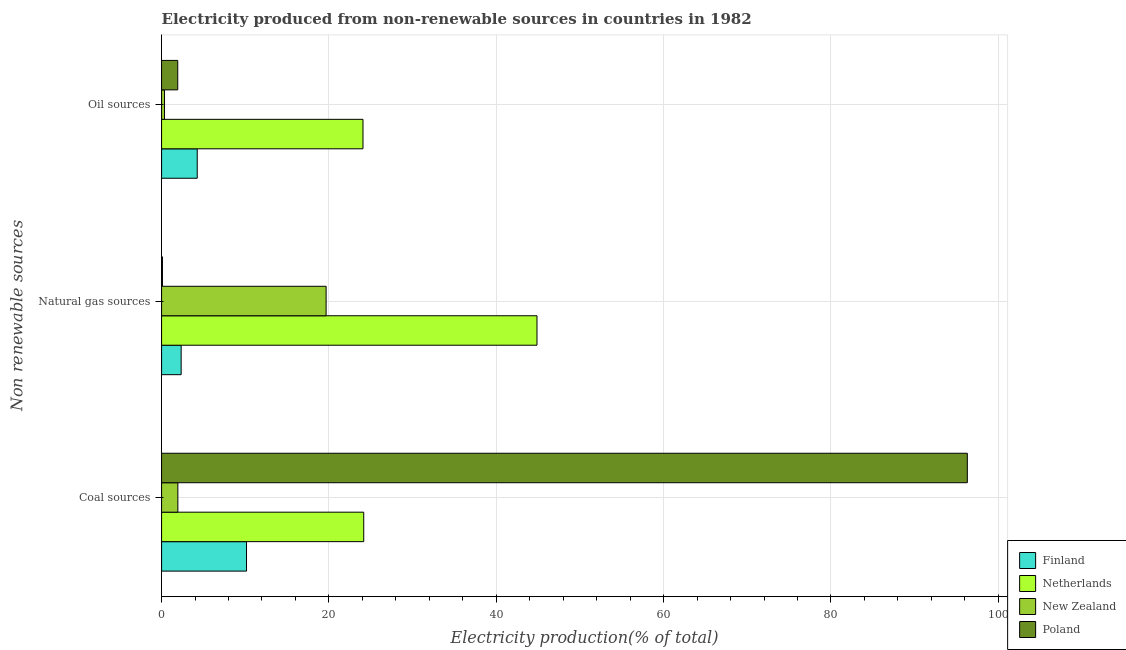How many different coloured bars are there?
Offer a terse response. 4. Are the number of bars per tick equal to the number of legend labels?
Provide a succinct answer. Yes. How many bars are there on the 1st tick from the top?
Ensure brevity in your answer.  4. What is the label of the 3rd group of bars from the top?
Your answer should be very brief. Coal sources. What is the percentage of electricity produced by oil sources in Finland?
Keep it short and to the point. 4.26. Across all countries, what is the maximum percentage of electricity produced by natural gas?
Give a very brief answer. 44.87. Across all countries, what is the minimum percentage of electricity produced by oil sources?
Give a very brief answer. 0.35. In which country was the percentage of electricity produced by coal minimum?
Provide a succinct answer. New Zealand. What is the total percentage of electricity produced by coal in the graph?
Give a very brief answer. 132.56. What is the difference between the percentage of electricity produced by oil sources in Netherlands and that in New Zealand?
Your response must be concise. 23.72. What is the difference between the percentage of electricity produced by coal in Netherlands and the percentage of electricity produced by natural gas in New Zealand?
Your answer should be compact. 4.5. What is the average percentage of electricity produced by oil sources per country?
Provide a short and direct response. 7.65. What is the difference between the percentage of electricity produced by natural gas and percentage of electricity produced by coal in Finland?
Give a very brief answer. -7.81. What is the ratio of the percentage of electricity produced by oil sources in Poland to that in New Zealand?
Your answer should be very brief. 5.48. Is the percentage of electricity produced by natural gas in Netherlands less than that in Finland?
Your answer should be compact. No. Is the difference between the percentage of electricity produced by natural gas in Finland and Poland greater than the difference between the percentage of electricity produced by coal in Finland and Poland?
Your answer should be very brief. Yes. What is the difference between the highest and the second highest percentage of electricity produced by oil sources?
Your answer should be very brief. 19.81. What is the difference between the highest and the lowest percentage of electricity produced by oil sources?
Provide a short and direct response. 23.72. In how many countries, is the percentage of electricity produced by natural gas greater than the average percentage of electricity produced by natural gas taken over all countries?
Make the answer very short. 2. What does the 1st bar from the bottom in Natural gas sources represents?
Provide a short and direct response. Finland. How many bars are there?
Give a very brief answer. 12. Are all the bars in the graph horizontal?
Offer a very short reply. Yes. How many countries are there in the graph?
Give a very brief answer. 4. Are the values on the major ticks of X-axis written in scientific E-notation?
Make the answer very short. No. Does the graph contain any zero values?
Your answer should be very brief. No. Does the graph contain grids?
Offer a terse response. Yes. Where does the legend appear in the graph?
Your answer should be compact. Bottom right. How many legend labels are there?
Provide a succinct answer. 4. How are the legend labels stacked?
Offer a very short reply. Vertical. What is the title of the graph?
Offer a very short reply. Electricity produced from non-renewable sources in countries in 1982. What is the label or title of the X-axis?
Offer a very short reply. Electricity production(% of total). What is the label or title of the Y-axis?
Your response must be concise. Non renewable sources. What is the Electricity production(% of total) in Finland in Coal sources?
Provide a short and direct response. 10.15. What is the Electricity production(% of total) in Netherlands in Coal sources?
Your answer should be compact. 24.16. What is the Electricity production(% of total) in New Zealand in Coal sources?
Keep it short and to the point. 1.95. What is the Electricity production(% of total) of Poland in Coal sources?
Provide a succinct answer. 96.3. What is the Electricity production(% of total) in Finland in Natural gas sources?
Offer a very short reply. 2.34. What is the Electricity production(% of total) of Netherlands in Natural gas sources?
Ensure brevity in your answer.  44.87. What is the Electricity production(% of total) in New Zealand in Natural gas sources?
Provide a short and direct response. 19.66. What is the Electricity production(% of total) in Poland in Natural gas sources?
Make the answer very short. 0.11. What is the Electricity production(% of total) in Finland in Oil sources?
Keep it short and to the point. 4.26. What is the Electricity production(% of total) in Netherlands in Oil sources?
Your response must be concise. 24.07. What is the Electricity production(% of total) of New Zealand in Oil sources?
Provide a succinct answer. 0.35. What is the Electricity production(% of total) of Poland in Oil sources?
Provide a succinct answer. 1.93. Across all Non renewable sources, what is the maximum Electricity production(% of total) of Finland?
Offer a very short reply. 10.15. Across all Non renewable sources, what is the maximum Electricity production(% of total) in Netherlands?
Offer a very short reply. 44.87. Across all Non renewable sources, what is the maximum Electricity production(% of total) of New Zealand?
Offer a very short reply. 19.66. Across all Non renewable sources, what is the maximum Electricity production(% of total) in Poland?
Your answer should be very brief. 96.3. Across all Non renewable sources, what is the minimum Electricity production(% of total) of Finland?
Offer a very short reply. 2.34. Across all Non renewable sources, what is the minimum Electricity production(% of total) of Netherlands?
Give a very brief answer. 24.07. Across all Non renewable sources, what is the minimum Electricity production(% of total) in New Zealand?
Your answer should be compact. 0.35. Across all Non renewable sources, what is the minimum Electricity production(% of total) in Poland?
Provide a succinct answer. 0.11. What is the total Electricity production(% of total) in Finland in the graph?
Provide a succinct answer. 16.76. What is the total Electricity production(% of total) of Netherlands in the graph?
Provide a short and direct response. 93.1. What is the total Electricity production(% of total) of New Zealand in the graph?
Your response must be concise. 21.96. What is the total Electricity production(% of total) of Poland in the graph?
Your response must be concise. 98.34. What is the difference between the Electricity production(% of total) of Finland in Coal sources and that in Natural gas sources?
Offer a terse response. 7.81. What is the difference between the Electricity production(% of total) of Netherlands in Coal sources and that in Natural gas sources?
Offer a terse response. -20.71. What is the difference between the Electricity production(% of total) of New Zealand in Coal sources and that in Natural gas sources?
Your answer should be compact. -17.72. What is the difference between the Electricity production(% of total) in Poland in Coal sources and that in Natural gas sources?
Your response must be concise. 96.19. What is the difference between the Electricity production(% of total) of Finland in Coal sources and that in Oil sources?
Keep it short and to the point. 5.89. What is the difference between the Electricity production(% of total) of Netherlands in Coal sources and that in Oil sources?
Your answer should be very brief. 0.09. What is the difference between the Electricity production(% of total) in New Zealand in Coal sources and that in Oil sources?
Offer a terse response. 1.59. What is the difference between the Electricity production(% of total) of Poland in Coal sources and that in Oil sources?
Offer a very short reply. 94.37. What is the difference between the Electricity production(% of total) of Finland in Natural gas sources and that in Oil sources?
Offer a terse response. -1.92. What is the difference between the Electricity production(% of total) of Netherlands in Natural gas sources and that in Oil sources?
Keep it short and to the point. 20.8. What is the difference between the Electricity production(% of total) in New Zealand in Natural gas sources and that in Oil sources?
Offer a terse response. 19.31. What is the difference between the Electricity production(% of total) of Poland in Natural gas sources and that in Oil sources?
Give a very brief answer. -1.83. What is the difference between the Electricity production(% of total) of Finland in Coal sources and the Electricity production(% of total) of Netherlands in Natural gas sources?
Keep it short and to the point. -34.71. What is the difference between the Electricity production(% of total) of Finland in Coal sources and the Electricity production(% of total) of New Zealand in Natural gas sources?
Provide a short and direct response. -9.51. What is the difference between the Electricity production(% of total) of Finland in Coal sources and the Electricity production(% of total) of Poland in Natural gas sources?
Provide a succinct answer. 10.05. What is the difference between the Electricity production(% of total) in Netherlands in Coal sources and the Electricity production(% of total) in New Zealand in Natural gas sources?
Provide a short and direct response. 4.5. What is the difference between the Electricity production(% of total) of Netherlands in Coal sources and the Electricity production(% of total) of Poland in Natural gas sources?
Give a very brief answer. 24.06. What is the difference between the Electricity production(% of total) in New Zealand in Coal sources and the Electricity production(% of total) in Poland in Natural gas sources?
Provide a short and direct response. 1.84. What is the difference between the Electricity production(% of total) of Finland in Coal sources and the Electricity production(% of total) of Netherlands in Oil sources?
Your response must be concise. -13.92. What is the difference between the Electricity production(% of total) in Finland in Coal sources and the Electricity production(% of total) in New Zealand in Oil sources?
Your response must be concise. 9.8. What is the difference between the Electricity production(% of total) of Finland in Coal sources and the Electricity production(% of total) of Poland in Oil sources?
Offer a very short reply. 8.22. What is the difference between the Electricity production(% of total) in Netherlands in Coal sources and the Electricity production(% of total) in New Zealand in Oil sources?
Make the answer very short. 23.81. What is the difference between the Electricity production(% of total) in Netherlands in Coal sources and the Electricity production(% of total) in Poland in Oil sources?
Give a very brief answer. 22.23. What is the difference between the Electricity production(% of total) in New Zealand in Coal sources and the Electricity production(% of total) in Poland in Oil sources?
Provide a short and direct response. 0.01. What is the difference between the Electricity production(% of total) of Finland in Natural gas sources and the Electricity production(% of total) of Netherlands in Oil sources?
Make the answer very short. -21.73. What is the difference between the Electricity production(% of total) in Finland in Natural gas sources and the Electricity production(% of total) in New Zealand in Oil sources?
Give a very brief answer. 1.99. What is the difference between the Electricity production(% of total) in Finland in Natural gas sources and the Electricity production(% of total) in Poland in Oil sources?
Your answer should be compact. 0.41. What is the difference between the Electricity production(% of total) in Netherlands in Natural gas sources and the Electricity production(% of total) in New Zealand in Oil sources?
Your answer should be very brief. 44.51. What is the difference between the Electricity production(% of total) of Netherlands in Natural gas sources and the Electricity production(% of total) of Poland in Oil sources?
Keep it short and to the point. 42.93. What is the difference between the Electricity production(% of total) in New Zealand in Natural gas sources and the Electricity production(% of total) in Poland in Oil sources?
Your answer should be compact. 17.73. What is the average Electricity production(% of total) of Finland per Non renewable sources?
Make the answer very short. 5.59. What is the average Electricity production(% of total) in Netherlands per Non renewable sources?
Offer a terse response. 31.03. What is the average Electricity production(% of total) of New Zealand per Non renewable sources?
Offer a very short reply. 7.32. What is the average Electricity production(% of total) in Poland per Non renewable sources?
Keep it short and to the point. 32.78. What is the difference between the Electricity production(% of total) in Finland and Electricity production(% of total) in Netherlands in Coal sources?
Provide a succinct answer. -14.01. What is the difference between the Electricity production(% of total) in Finland and Electricity production(% of total) in New Zealand in Coal sources?
Keep it short and to the point. 8.21. What is the difference between the Electricity production(% of total) in Finland and Electricity production(% of total) in Poland in Coal sources?
Your response must be concise. -86.15. What is the difference between the Electricity production(% of total) of Netherlands and Electricity production(% of total) of New Zealand in Coal sources?
Your response must be concise. 22.21. What is the difference between the Electricity production(% of total) in Netherlands and Electricity production(% of total) in Poland in Coal sources?
Your response must be concise. -72.14. What is the difference between the Electricity production(% of total) in New Zealand and Electricity production(% of total) in Poland in Coal sources?
Ensure brevity in your answer.  -94.35. What is the difference between the Electricity production(% of total) in Finland and Electricity production(% of total) in Netherlands in Natural gas sources?
Provide a succinct answer. -42.53. What is the difference between the Electricity production(% of total) of Finland and Electricity production(% of total) of New Zealand in Natural gas sources?
Provide a succinct answer. -17.32. What is the difference between the Electricity production(% of total) of Finland and Electricity production(% of total) of Poland in Natural gas sources?
Offer a terse response. 2.24. What is the difference between the Electricity production(% of total) in Netherlands and Electricity production(% of total) in New Zealand in Natural gas sources?
Offer a terse response. 25.2. What is the difference between the Electricity production(% of total) of Netherlands and Electricity production(% of total) of Poland in Natural gas sources?
Provide a short and direct response. 44.76. What is the difference between the Electricity production(% of total) of New Zealand and Electricity production(% of total) of Poland in Natural gas sources?
Ensure brevity in your answer.  19.56. What is the difference between the Electricity production(% of total) of Finland and Electricity production(% of total) of Netherlands in Oil sources?
Your response must be concise. -19.81. What is the difference between the Electricity production(% of total) of Finland and Electricity production(% of total) of New Zealand in Oil sources?
Make the answer very short. 3.91. What is the difference between the Electricity production(% of total) in Finland and Electricity production(% of total) in Poland in Oil sources?
Keep it short and to the point. 2.33. What is the difference between the Electricity production(% of total) in Netherlands and Electricity production(% of total) in New Zealand in Oil sources?
Your response must be concise. 23.72. What is the difference between the Electricity production(% of total) of Netherlands and Electricity production(% of total) of Poland in Oil sources?
Provide a succinct answer. 22.14. What is the difference between the Electricity production(% of total) of New Zealand and Electricity production(% of total) of Poland in Oil sources?
Offer a terse response. -1.58. What is the ratio of the Electricity production(% of total) in Finland in Coal sources to that in Natural gas sources?
Make the answer very short. 4.34. What is the ratio of the Electricity production(% of total) in Netherlands in Coal sources to that in Natural gas sources?
Provide a succinct answer. 0.54. What is the ratio of the Electricity production(% of total) of New Zealand in Coal sources to that in Natural gas sources?
Ensure brevity in your answer.  0.1. What is the ratio of the Electricity production(% of total) of Poland in Coal sources to that in Natural gas sources?
Provide a succinct answer. 912.42. What is the ratio of the Electricity production(% of total) in Finland in Coal sources to that in Oil sources?
Provide a short and direct response. 2.38. What is the ratio of the Electricity production(% of total) of Netherlands in Coal sources to that in Oil sources?
Offer a terse response. 1. What is the ratio of the Electricity production(% of total) of New Zealand in Coal sources to that in Oil sources?
Ensure brevity in your answer.  5.52. What is the ratio of the Electricity production(% of total) of Poland in Coal sources to that in Oil sources?
Make the answer very short. 49.83. What is the ratio of the Electricity production(% of total) of Finland in Natural gas sources to that in Oil sources?
Offer a very short reply. 0.55. What is the ratio of the Electricity production(% of total) of Netherlands in Natural gas sources to that in Oil sources?
Make the answer very short. 1.86. What is the ratio of the Electricity production(% of total) of New Zealand in Natural gas sources to that in Oil sources?
Offer a terse response. 55.8. What is the ratio of the Electricity production(% of total) in Poland in Natural gas sources to that in Oil sources?
Offer a terse response. 0.05. What is the difference between the highest and the second highest Electricity production(% of total) in Finland?
Offer a terse response. 5.89. What is the difference between the highest and the second highest Electricity production(% of total) of Netherlands?
Your response must be concise. 20.71. What is the difference between the highest and the second highest Electricity production(% of total) in New Zealand?
Ensure brevity in your answer.  17.72. What is the difference between the highest and the second highest Electricity production(% of total) in Poland?
Give a very brief answer. 94.37. What is the difference between the highest and the lowest Electricity production(% of total) of Finland?
Your response must be concise. 7.81. What is the difference between the highest and the lowest Electricity production(% of total) of Netherlands?
Your response must be concise. 20.8. What is the difference between the highest and the lowest Electricity production(% of total) of New Zealand?
Ensure brevity in your answer.  19.31. What is the difference between the highest and the lowest Electricity production(% of total) of Poland?
Offer a very short reply. 96.19. 